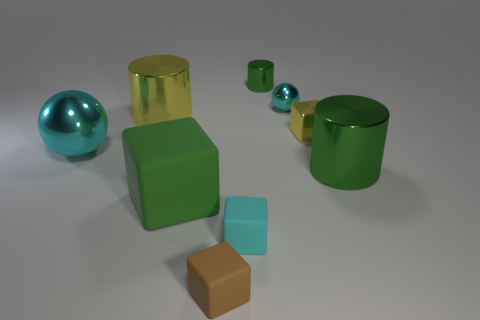What number of objects are spheres on the right side of the cyan matte object or green metallic things to the left of the metal cube?
Make the answer very short. 2. There is a object that is behind the large yellow object and to the right of the tiny cylinder; what material is it?
Your answer should be very brief. Metal. What size is the green cylinder that is behind the yellow object that is to the left of the tiny cyan ball that is behind the tiny brown thing?
Give a very brief answer. Small. Are there more yellow shiny blocks than red matte cylinders?
Ensure brevity in your answer.  Yes. Is the material of the green thing on the right side of the tiny yellow object the same as the large cyan ball?
Ensure brevity in your answer.  Yes. Are there fewer green rubber balls than green blocks?
Offer a terse response. Yes. Is there a ball that is to the left of the large cylinder on the left side of the large shiny cylinder in front of the tiny yellow cube?
Give a very brief answer. Yes. Do the shiny object that is in front of the large metallic sphere and the big yellow object have the same shape?
Give a very brief answer. Yes. Is the number of big green matte blocks that are on the right side of the small brown matte object greater than the number of red matte cubes?
Your answer should be very brief. No. Does the large cylinder left of the tiny green shiny thing have the same color as the shiny cube?
Offer a very short reply. Yes. 